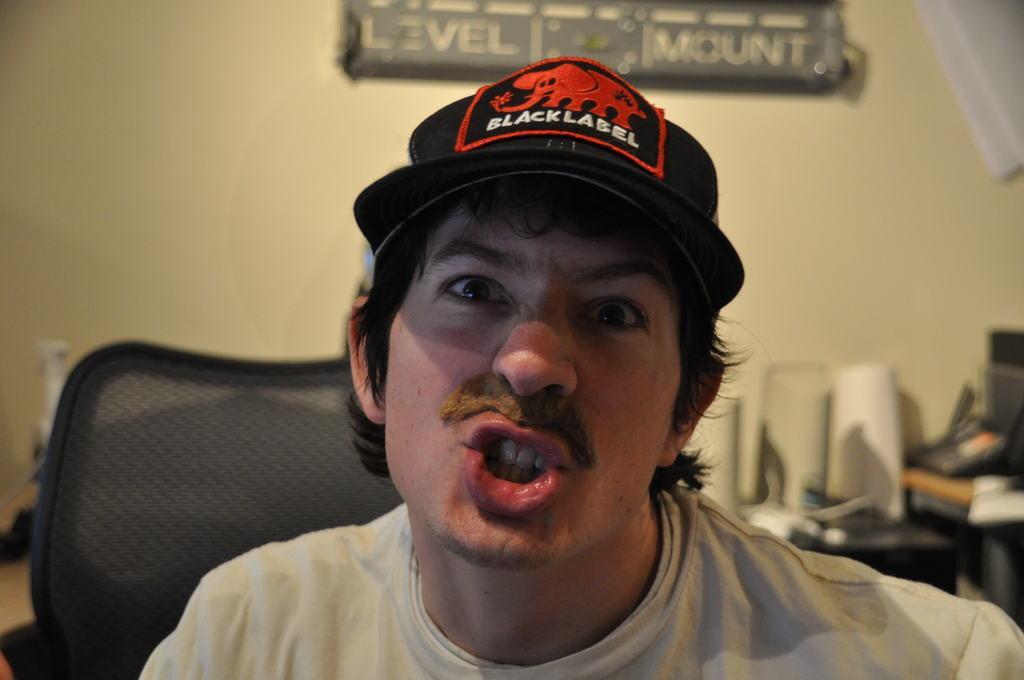In one or two sentences, can you explain what this image depicts? In the image we can see there is a man sitting and he is wearing black colour cap. It's written ¨Black Label¨ and there is a chair. There are paper rolls kept on the table and behind there is a small hoarding on the wall. Background of the image is little blurred. 